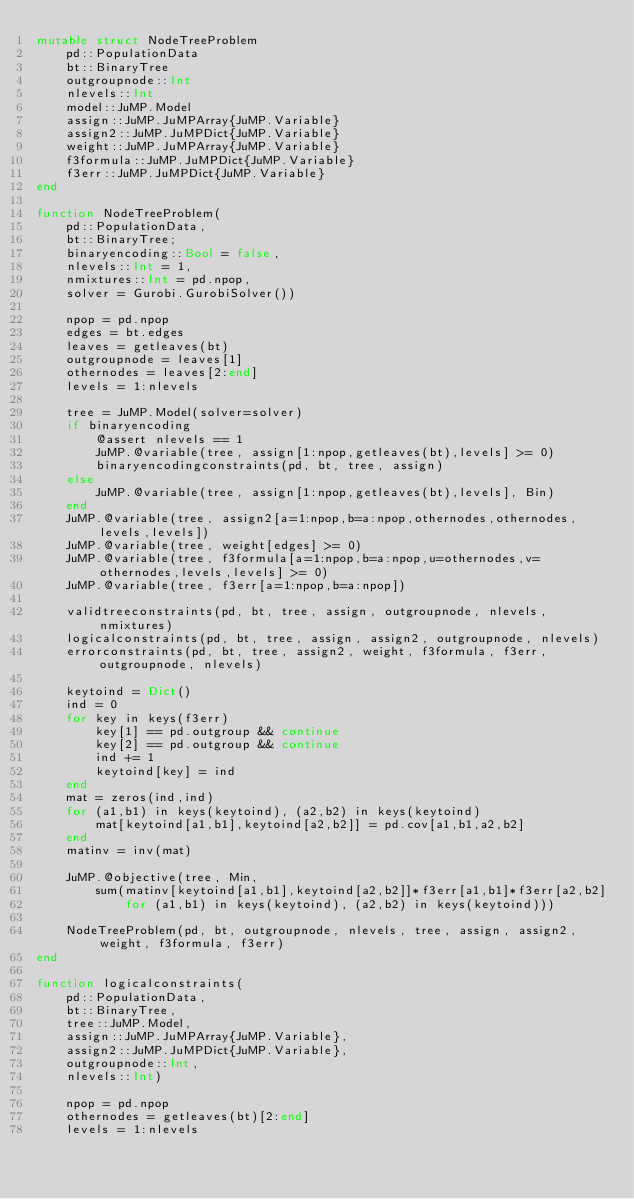Convert code to text. <code><loc_0><loc_0><loc_500><loc_500><_Julia_>mutable struct NodeTreeProblem
    pd::PopulationData
    bt::BinaryTree
    outgroupnode::Int
    nlevels::Int
    model::JuMP.Model
    assign::JuMP.JuMPArray{JuMP.Variable}
    assign2::JuMP.JuMPDict{JuMP.Variable}
    weight::JuMP.JuMPArray{JuMP.Variable}
    f3formula::JuMP.JuMPDict{JuMP.Variable}
    f3err::JuMP.JuMPDict{JuMP.Variable}
end 

function NodeTreeProblem(
    pd::PopulationData, 
    bt::BinaryTree;
    binaryencoding::Bool = false,
    nlevels::Int = 1,
    nmixtures::Int = pd.npop,
    solver = Gurobi.GurobiSolver())
    
    npop = pd.npop
    edges = bt.edges
    leaves = getleaves(bt)
    outgroupnode = leaves[1]
    othernodes = leaves[2:end]
    levels = 1:nlevels

    tree = JuMP.Model(solver=solver)
    if binaryencoding
        @assert nlevels == 1
        JuMP.@variable(tree, assign[1:npop,getleaves(bt),levels] >= 0)
        binaryencodingconstraints(pd, bt, tree, assign)
    else 
        JuMP.@variable(tree, assign[1:npop,getleaves(bt),levels], Bin)
    end
    JuMP.@variable(tree, assign2[a=1:npop,b=a:npop,othernodes,othernodes,levels,levels])
    JuMP.@variable(tree, weight[edges] >= 0)
    JuMP.@variable(tree, f3formula[a=1:npop,b=a:npop,u=othernodes,v=othernodes,levels,levels] >= 0)
    JuMP.@variable(tree, f3err[a=1:npop,b=a:npop])
 
    validtreeconstraints(pd, bt, tree, assign, outgroupnode, nlevels, nmixtures)
    logicalconstraints(pd, bt, tree, assign, assign2, outgroupnode, nlevels)
    errorconstraints(pd, bt, tree, assign2, weight, f3formula, f3err, outgroupnode, nlevels)
    
    keytoind = Dict()
    ind = 0
    for key in keys(f3err)
        key[1] == pd.outgroup && continue
        key[2] == pd.outgroup && continue
        ind += 1
        keytoind[key] = ind
    end
    mat = zeros(ind,ind)
    for (a1,b1) in keys(keytoind), (a2,b2) in keys(keytoind)
        mat[keytoind[a1,b1],keytoind[a2,b2]] = pd.cov[a1,b1,a2,b2]
    end
    matinv = inv(mat)
    
    JuMP.@objective(tree, Min, 
        sum(matinv[keytoind[a1,b1],keytoind[a2,b2]]*f3err[a1,b1]*f3err[a2,b2]
            for (a1,b1) in keys(keytoind), (a2,b2) in keys(keytoind)))

    NodeTreeProblem(pd, bt, outgroupnode, nlevels, tree, assign, assign2, weight, f3formula, f3err)
end

function logicalconstraints(
    pd::PopulationData, 
    bt::BinaryTree,
    tree::JuMP.Model, 
    assign::JuMP.JuMPArray{JuMP.Variable},
    assign2::JuMP.JuMPDict{JuMP.Variable},
    outgroupnode::Int,
    nlevels::Int)

    npop = pd.npop
    othernodes = getleaves(bt)[2:end]
    levels = 1:nlevels
    </code> 